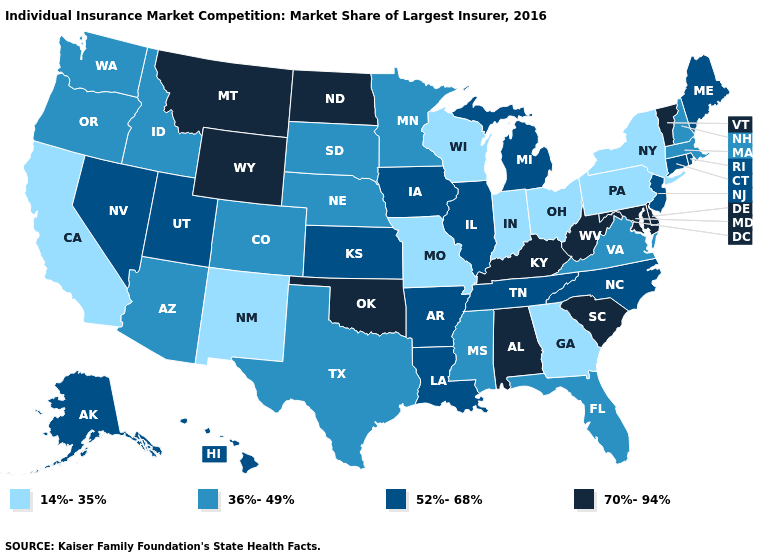Name the states that have a value in the range 70%-94%?
Keep it brief. Alabama, Delaware, Kentucky, Maryland, Montana, North Dakota, Oklahoma, South Carolina, Vermont, West Virginia, Wyoming. Does the first symbol in the legend represent the smallest category?
Keep it brief. Yes. Name the states that have a value in the range 70%-94%?
Give a very brief answer. Alabama, Delaware, Kentucky, Maryland, Montana, North Dakota, Oklahoma, South Carolina, Vermont, West Virginia, Wyoming. Name the states that have a value in the range 36%-49%?
Quick response, please. Arizona, Colorado, Florida, Idaho, Massachusetts, Minnesota, Mississippi, Nebraska, New Hampshire, Oregon, South Dakota, Texas, Virginia, Washington. Does Kansas have the same value as Arizona?
Concise answer only. No. What is the highest value in states that border Oregon?
Quick response, please. 52%-68%. Which states have the lowest value in the West?
Concise answer only. California, New Mexico. What is the value of Delaware?
Quick response, please. 70%-94%. Does Pennsylvania have the lowest value in the USA?
Quick response, please. Yes. Does Louisiana have a lower value than New York?
Answer briefly. No. What is the value of Virginia?
Be succinct. 36%-49%. Does South Carolina have a higher value than Delaware?
Short answer required. No. What is the lowest value in the USA?
Short answer required. 14%-35%. Name the states that have a value in the range 36%-49%?
Be succinct. Arizona, Colorado, Florida, Idaho, Massachusetts, Minnesota, Mississippi, Nebraska, New Hampshire, Oregon, South Dakota, Texas, Virginia, Washington. 